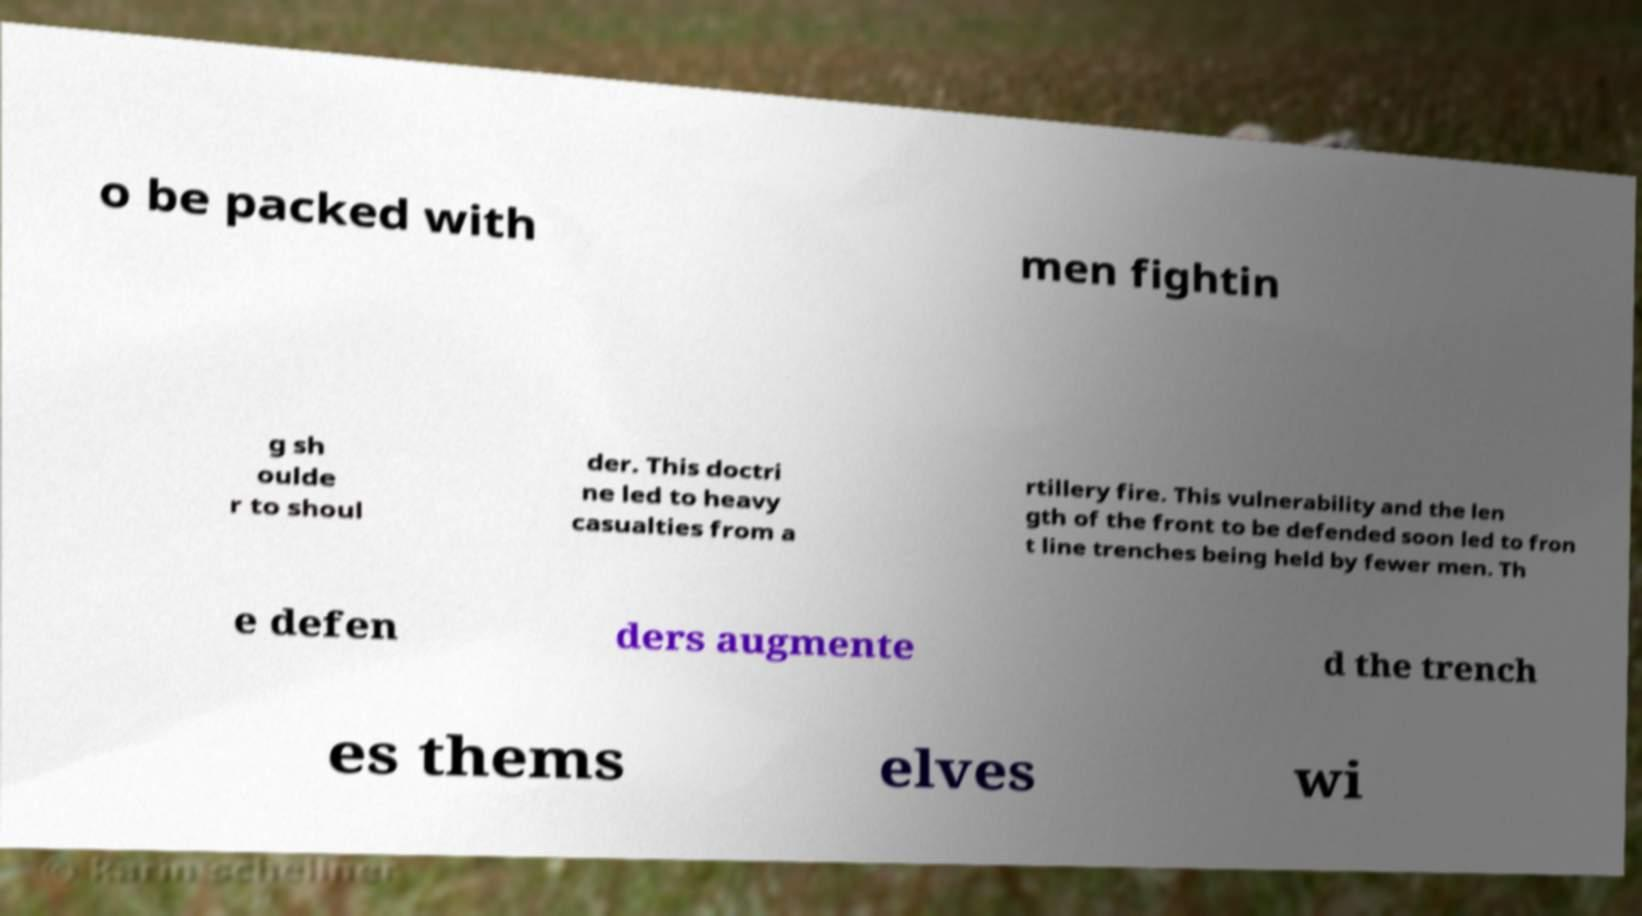Can you read and provide the text displayed in the image?This photo seems to have some interesting text. Can you extract and type it out for me? o be packed with men fightin g sh oulde r to shoul der. This doctri ne led to heavy casualties from a rtillery fire. This vulnerability and the len gth of the front to be defended soon led to fron t line trenches being held by fewer men. Th e defen ders augmente d the trench es thems elves wi 